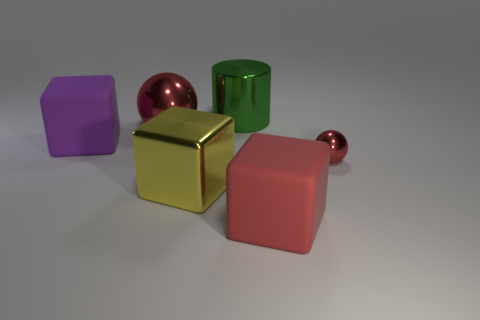Add 3 tiny red shiny balls. How many objects exist? 9 Subtract all cylinders. How many objects are left? 5 Subtract all green metal cylinders. Subtract all big metallic spheres. How many objects are left? 4 Add 5 red cubes. How many red cubes are left? 6 Add 6 metallic cylinders. How many metallic cylinders exist? 7 Subtract 0 gray cylinders. How many objects are left? 6 